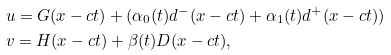Convert formula to latex. <formula><loc_0><loc_0><loc_500><loc_500>& u = G ( x - c t ) + ( \alpha _ { 0 } ( t ) d ^ { - } ( x - c t ) + \alpha _ { 1 } ( t ) d ^ { + } ( x - c t ) ) \\ & v = H ( x - c t ) + \beta ( t ) D ( x - c t ) ,</formula> 